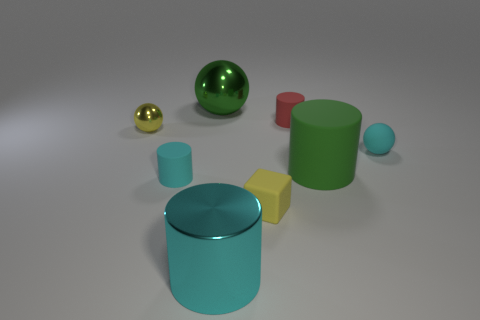There is a big thing that is the same color as the large rubber cylinder; what material is it?
Provide a short and direct response. Metal. What number of things are either tiny cyan matte objects on the left side of the red object or cylinders that are right of the tiny red cylinder?
Offer a very short reply. 2. Is the color of the tiny rubber ball the same as the tiny cylinder in front of the yellow shiny thing?
Your response must be concise. Yes. There is a green thing that is the same material as the tiny yellow ball; what is its shape?
Your answer should be very brief. Sphere. What number of small cyan cylinders are there?
Offer a terse response. 1. What number of objects are large things behind the small yellow metal object or purple metal things?
Make the answer very short. 1. There is a metal thing that is in front of the small cyan rubber sphere; is it the same color as the tiny matte sphere?
Make the answer very short. Yes. What number of other objects are there of the same color as the matte block?
Make the answer very short. 1. How many tiny things are either cyan shiny cylinders or blue cubes?
Provide a short and direct response. 0. Is the number of cyan shiny things greater than the number of big blue balls?
Provide a succinct answer. Yes. 